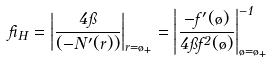Convert formula to latex. <formula><loc_0><loc_0><loc_500><loc_500>\beta _ { H } = \left | \frac { 4 \pi } { ( - N ^ { \prime } ( r ) ) } \right | _ { r = \tau _ { + } } = \left | \frac { - f ^ { \prime } ( \tau ) } { 4 \pi f ^ { 2 } ( \tau ) } \right | _ { \tau = \tau _ { + } } ^ { - 1 }</formula> 